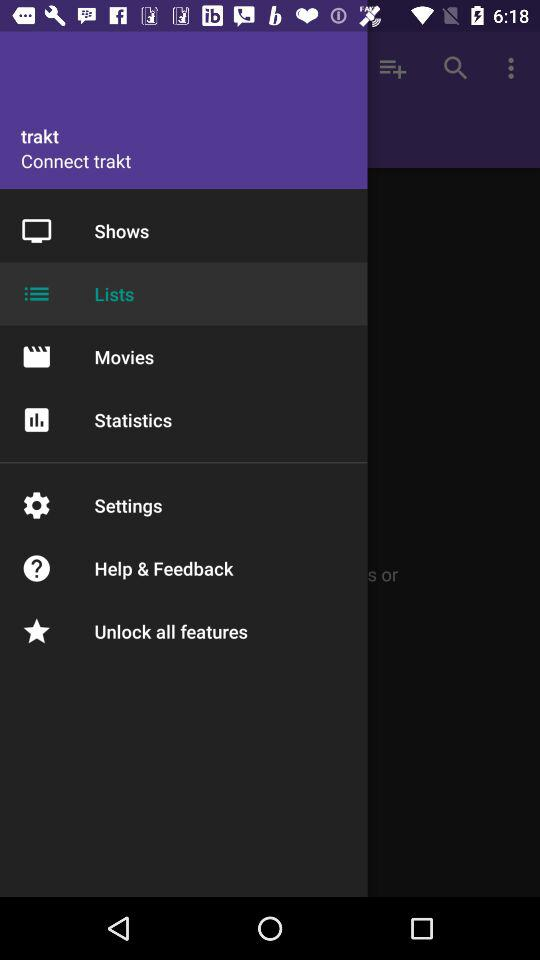Which item is selected? The selected item is "Lists". 